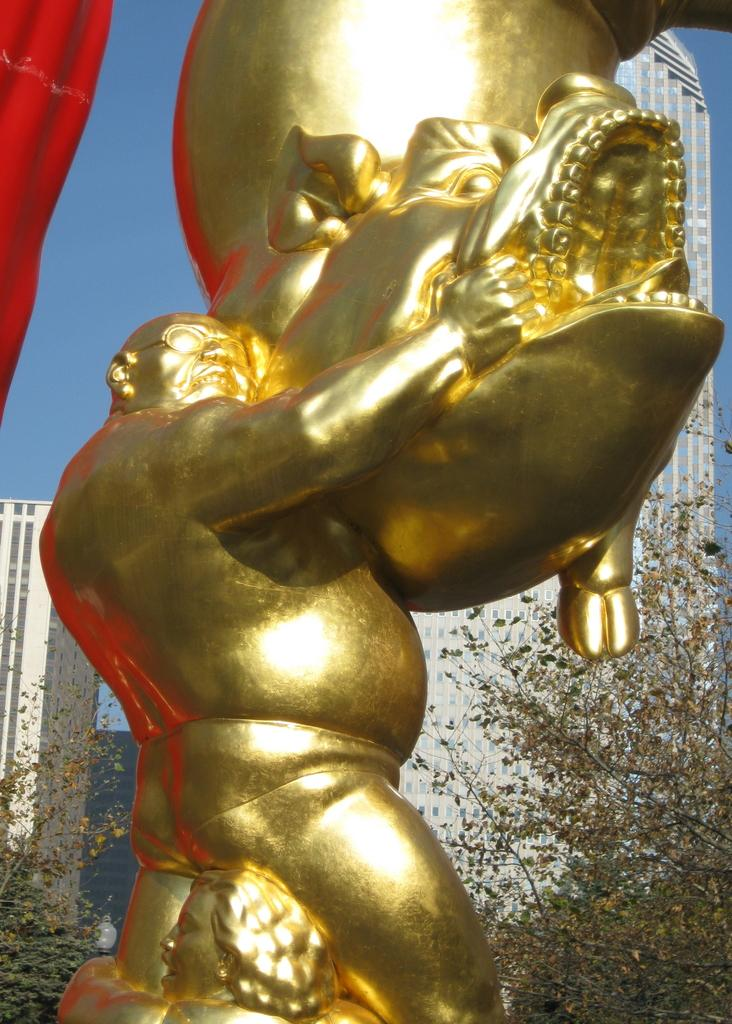What is the main subject of the image? There is a golden sculpture in the image. What can be seen on the left side of the image? The sky is visible on the left side of the image. Where is the grandfather sitting in the image? There is no grandfather present in the image. What type of sack is being used to cover the sculpture in the image? There is no sack or covering present on the golden sculpture in the image. 